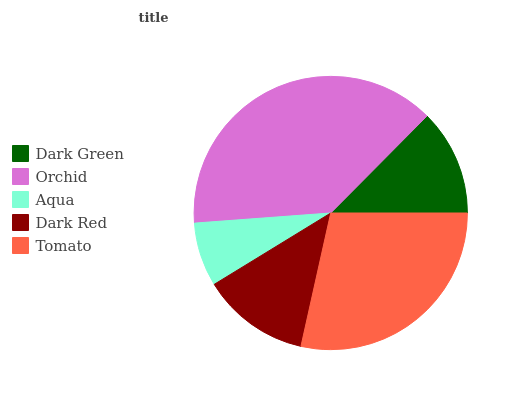Is Aqua the minimum?
Answer yes or no. Yes. Is Orchid the maximum?
Answer yes or no. Yes. Is Orchid the minimum?
Answer yes or no. No. Is Aqua the maximum?
Answer yes or no. No. Is Orchid greater than Aqua?
Answer yes or no. Yes. Is Aqua less than Orchid?
Answer yes or no. Yes. Is Aqua greater than Orchid?
Answer yes or no. No. Is Orchid less than Aqua?
Answer yes or no. No. Is Dark Red the high median?
Answer yes or no. Yes. Is Dark Red the low median?
Answer yes or no. Yes. Is Orchid the high median?
Answer yes or no. No. Is Aqua the low median?
Answer yes or no. No. 